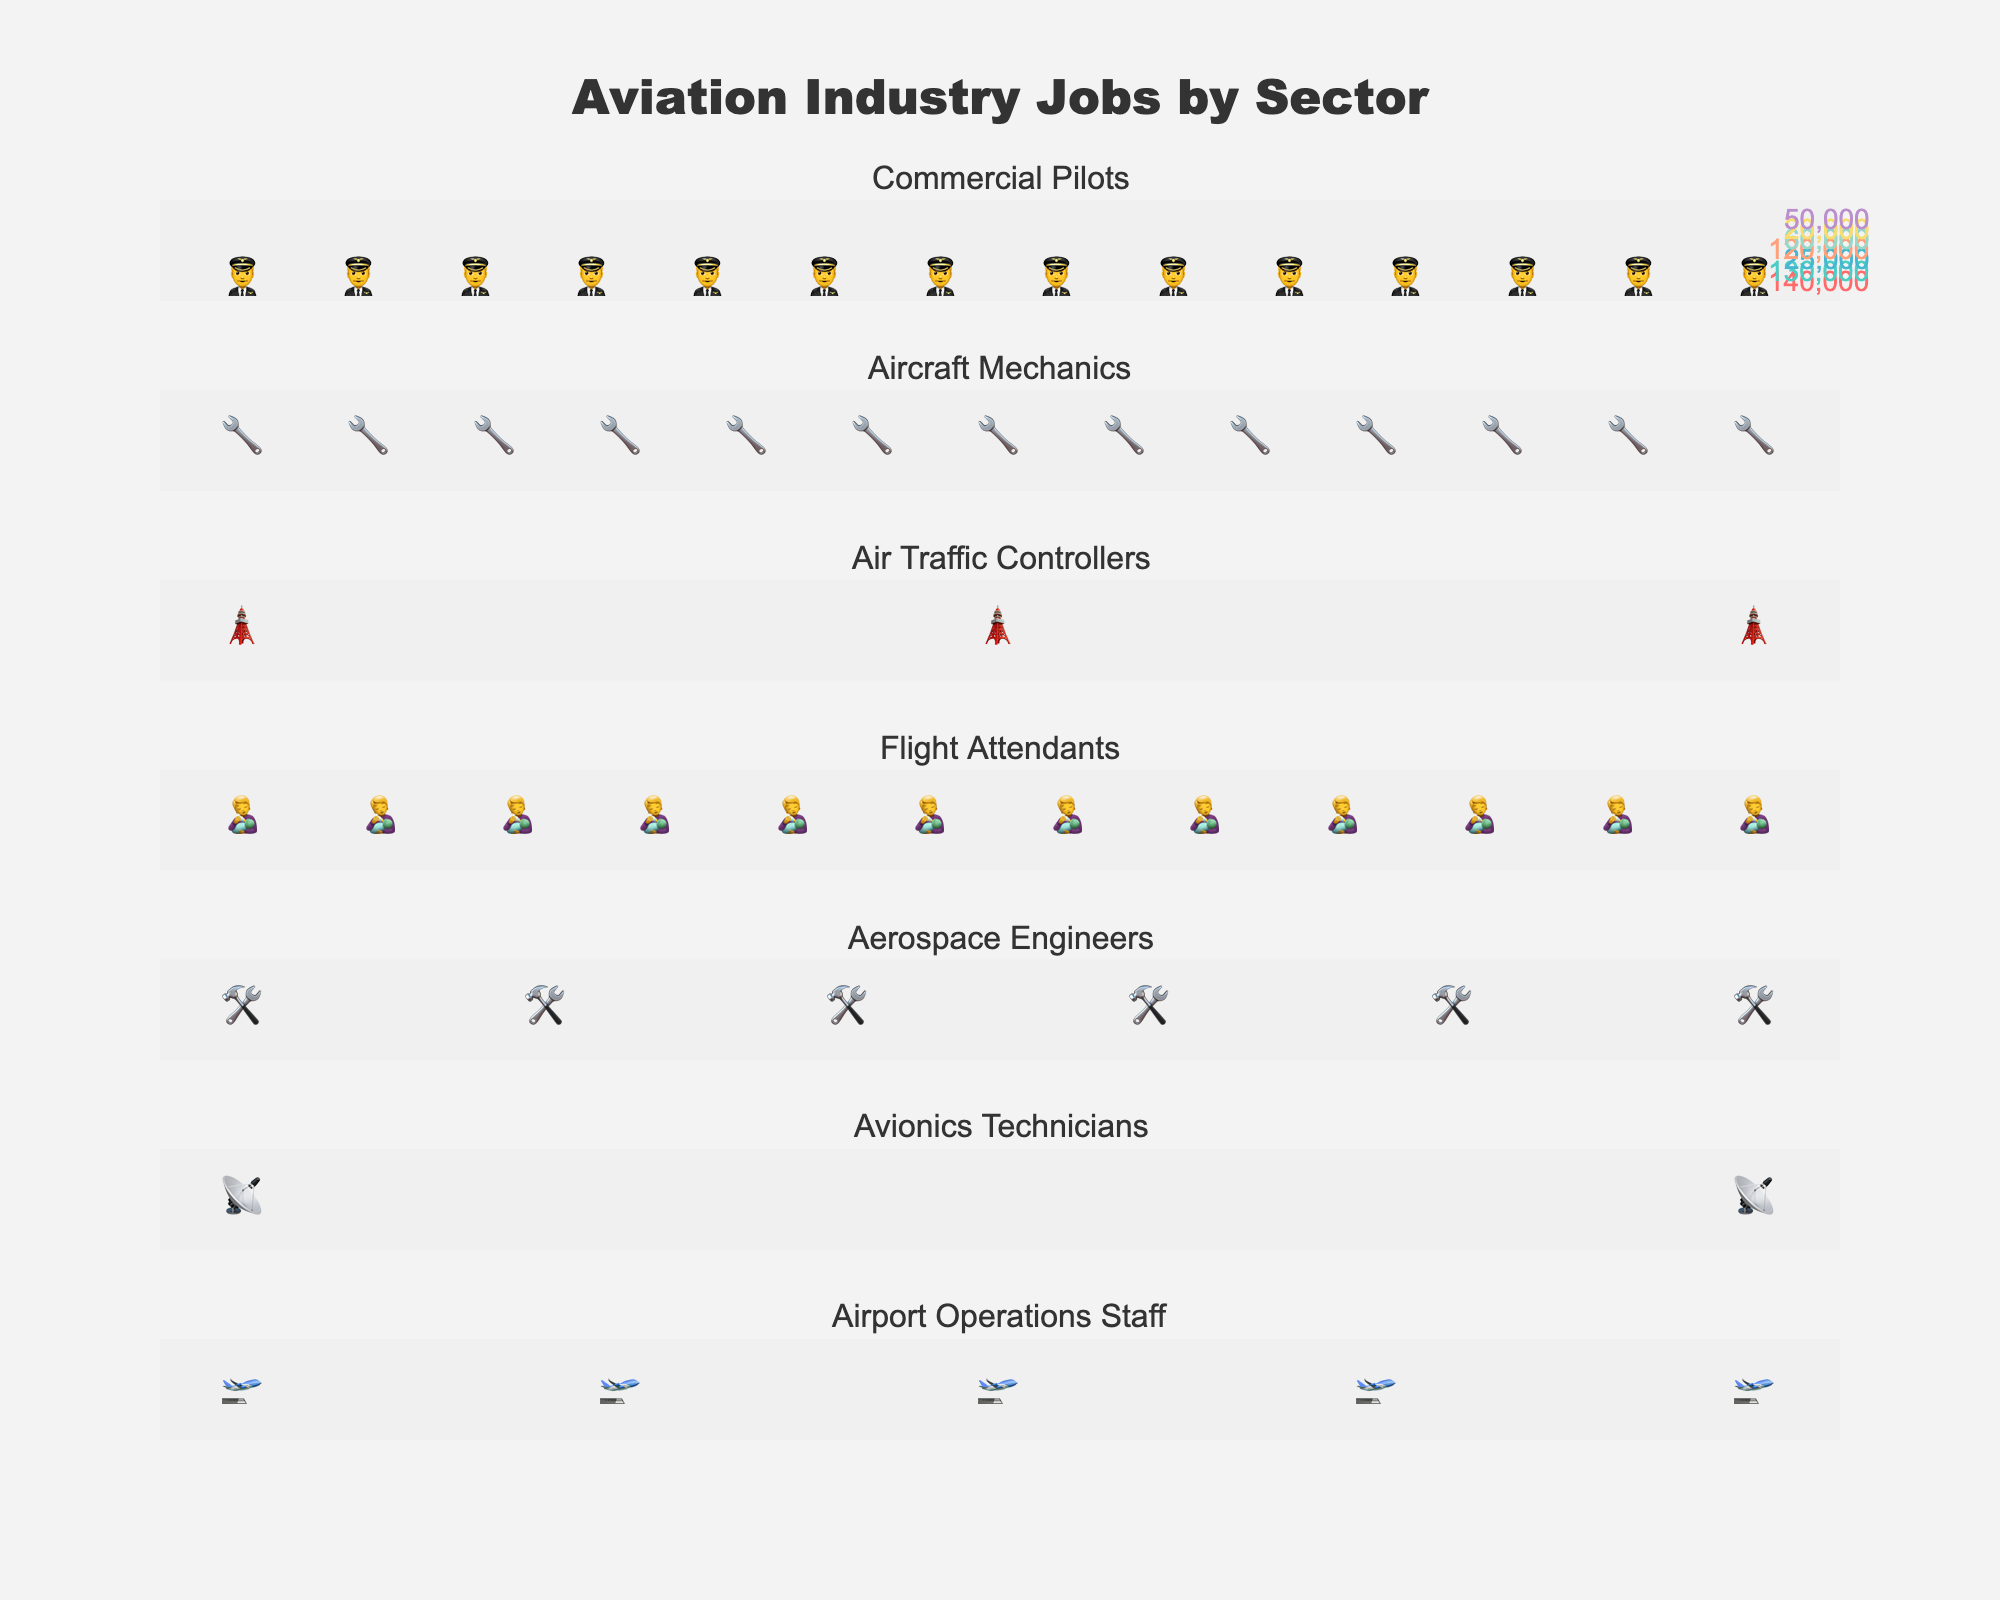Which job category has the highest number of jobs? The job category with the most icons represents the highest number of jobs. In the figure, the Commercial Pilots category has the most icons.
Answer: Commercial Pilots Which job category has the least number of jobs? The job category with the least icons represents the fewest number of jobs. In the figure, the Avionics Technicians category has the least icons.
Answer: Avionics Technicians How many icons are used for Aircraft Mechanics? Each icon represents 10,000 jobs. By counting the icons in the Aircraft Mechanics row, you can find the total number.
Answer: 13 What is the total number of jobs for Flight Attendants and Aerospace Engineers combined? Add the number of jobs from both categories: 120,000 for Flight Attendants and 60,000 for Aerospace Engineers. 120,000 + 60,000 = 180,000
Answer: 180,000 How many more jobs are there for Commercial Pilots than Air Traffic Controllers? Subtract the number of jobs for Air Traffic Controllers from Commercial Pilots: 140,000 - 25,000 = 115,000
Answer: 115,000 Which two job categories have a similar number of jobs? Look for job categories with a close number of icons. Flight Attendants and Aircraft Mechanics each have similar job counts (12 and 13 icons, respectively).
Answer: Flight Attendants and Aircraft Mechanics What is the approximate total number of jobs displayed in the figure? Sum the number of jobs for all categories: 140,000 + 130,000 + 25,000 + 120,000 + 60,000 + 20,000 + 50,000 = 545,000
Answer: 545,000 What is the average number of jobs per category? Divide the total number of jobs by the number of categories: 545,000 jobs / 7 categories ≈ 77,857 jobs
Answer: 77,857 Which category has exactly double the jobs of Avionics Technicians? The Avionics Technicians has 20,000 jobs. Doubling this gives 40,000 jobs. By checking the figure, there isn't a category with exactly this number, but Airport Operations Staff with 50,000 jobs is close if considering possible rounding in visual representation.
Answer: None exactly; closest is Airport Operations Staff with 50,000 